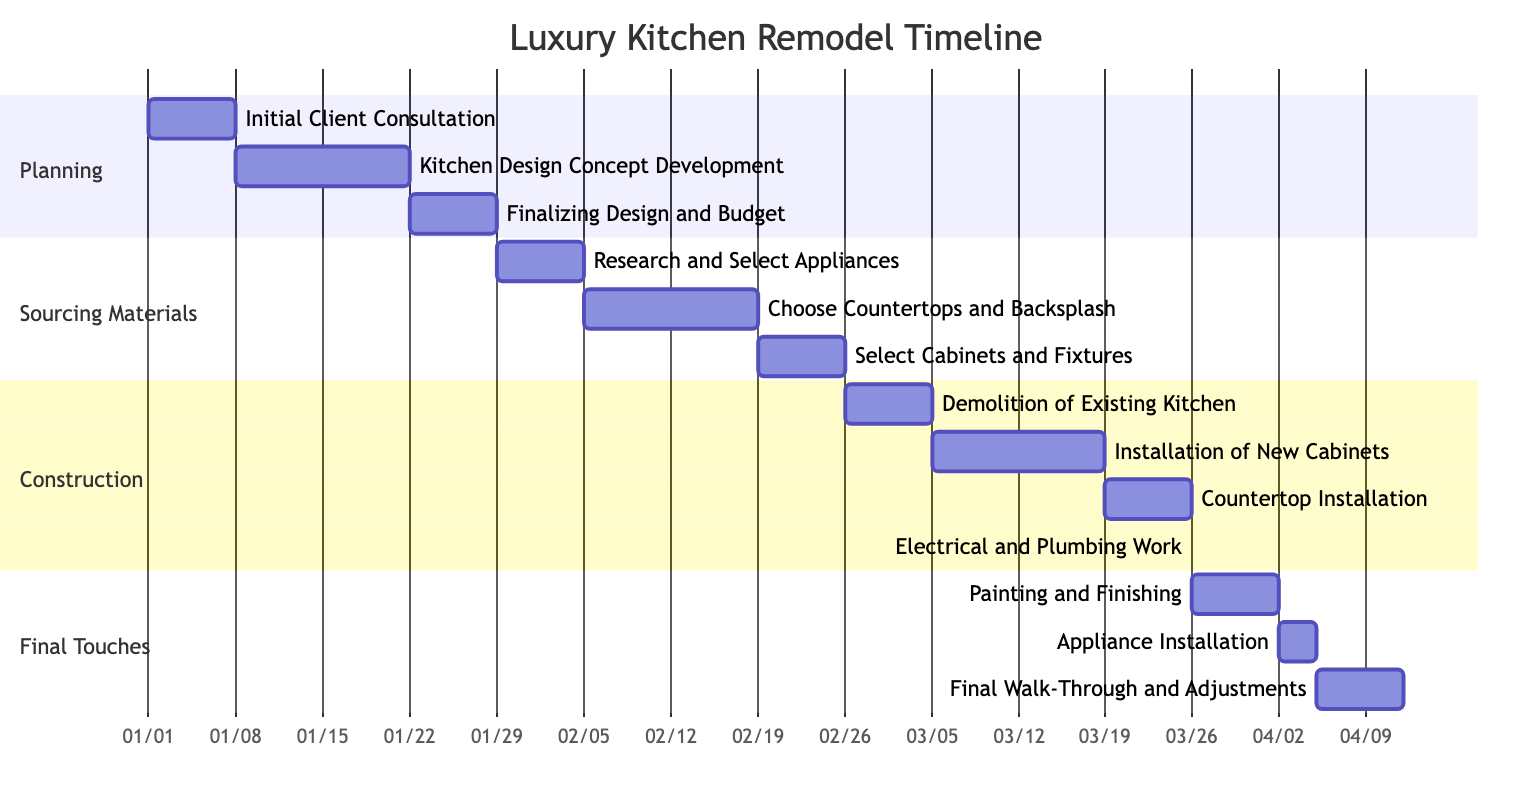What is the total duration of the Planning phase? The Planning phase consists of three tasks: Initial Client Consultation (1 week), Kitchen Design Concept Development (2 weeks), and Finalizing Design and Budget (1 week). Adding these durations together gives 1 + 2 + 1 = 4 weeks.
Answer: 4 weeks Which task immediately follows "Research and Select Appliances"? According to the diagram, the task "Choose Countertops and Backsplash" is placed directly after the task "Research and Select Appliances," indicating it starts when the previous task ends.
Answer: Choose Countertops and Backsplash How many weeks does the Construction phase take? The Construction phase includes four tasks with the following durations: Demolition of Existing Kitchen (1 week), Installation of New Cabinets (2 weeks), Countertop Installation (1 week), and Electrical and Plumbing Work (1.5 weeks). Calculating these gives 1 + 2 + 1 + 1.5 = 5.5 weeks.
Answer: 5.5 weeks What is the duration of the Electrical and Plumbing Work task? The task "Electrical and Plumbing Work" on the diagram has a duration of 1.5 weeks. This was specified directly in the task details within the Construction phase.
Answer: 1.5 weeks Which task is the last to occur in the project timeline? The final task in the timeline is "Final Walk-Through and Adjustments," which is positioned as the last task in the Final Touches phase.
Answer: Final Walk-Through and Adjustments How many tasks are there in total across all phases? By summing the number of tasks in each of the four phases: Planning (3 tasks), Sourcing Materials (3 tasks), Construction (4 tasks), and Final Touches (3 tasks), we get a total of 3 + 3 + 4 + 3 = 13 tasks.
Answer: 13 tasks Which phase contains the most tasks? Examining the number of tasks in each phase we have: Planning (3 tasks), Sourcing Materials (3 tasks), Construction (4 tasks), and Final Touches (3 tasks). The Construction phase has the highest count of tasks, totaling four.
Answer: Construction What activity takes the longest time in the Final Touches phase? In the Final Touches phase, the activities are Painting and Finishing (1 week), Appliance Installation (3 days), and Final Walk-Through and Adjustments (1 week). The longest duration among these is Painting and Finishing or Final Walk-Through and Adjustments, both at 1 week.
Answer: Painting and Finishing or Final Walk-Through and Adjustments 